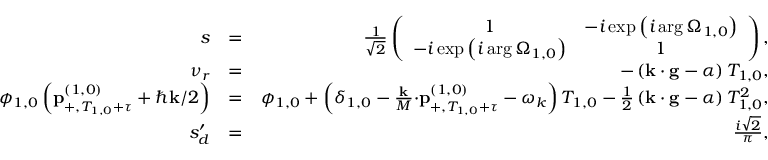<formula> <loc_0><loc_0><loc_500><loc_500>\begin{array} { r l r } { s } & { = } & { \frac { 1 } { \sqrt { 2 } } \left ( \begin{array} { c c } { 1 } & { - i \exp \left ( i \arg \Omega _ { 1 , 0 } \right ) } \\ { - i \exp \left ( i \arg \Omega _ { 1 , 0 } \right ) } & { 1 } \end{array} \right ) , } \\ { \nu _ { r } } & { = } & { - \left ( k \cdot g - \alpha \right ) T _ { 1 , 0 } , } \\ { \phi _ { 1 , 0 } \left ( p _ { + , T _ { 1 , 0 } + \tau } ^ { \left ( 1 , 0 \right ) } + \hbar { k } / 2 \right ) } & { = } & { \phi _ { 1 , 0 } + \left ( \delta _ { 1 , 0 } - \frac { k } { M } \cdot p _ { + , T _ { 1 , 0 } + \tau } ^ { \left ( 1 , 0 \right ) } - \omega _ { k } \right ) T _ { 1 , 0 } - \frac { 1 } { 2 } \left ( k \cdot g - \alpha \right ) T _ { 1 , 0 } ^ { 2 } , } \\ { s _ { d } ^ { \prime } } & { = } & { \frac { i \sqrt { 2 } } { \pi } , } \end{array}</formula> 